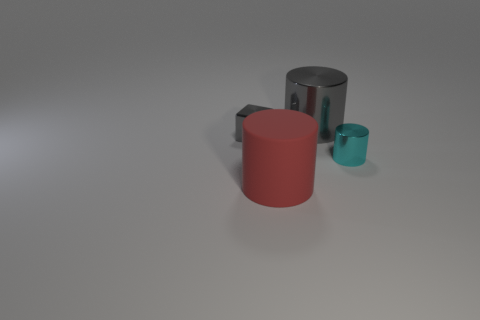Do the red rubber thing and the gray metallic cylinder have the same size? The red object and the gray cylinder do not have the same size. The red object appears to be a rubber cylinder and is noticeably shorter in height and smaller in diameter than the gray metallic cylinder. 